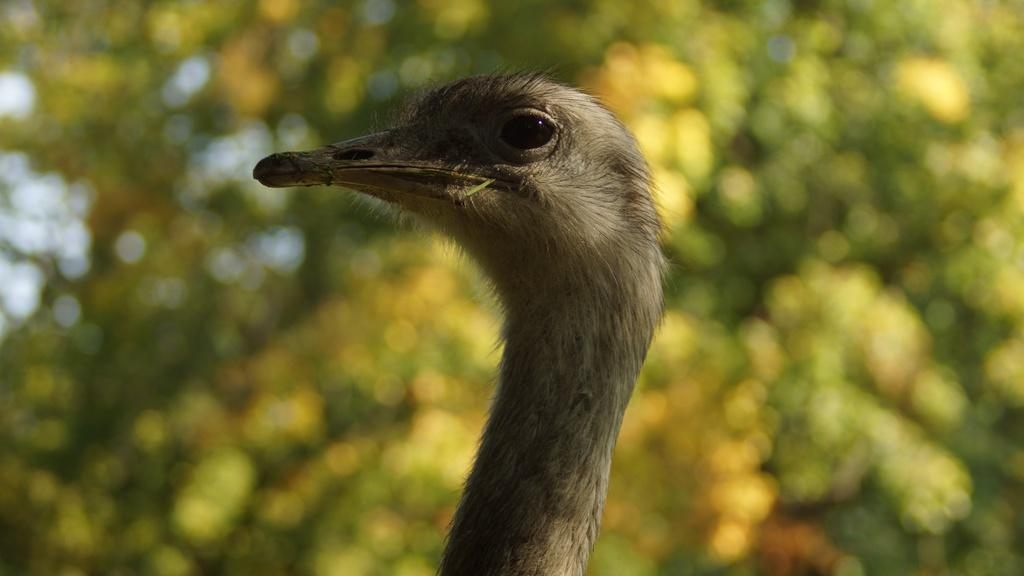What type of animal is in the image? There is a bird in the image. Can you describe the bird's appearance? The bird is cream-colored. What can be seen in the background of the image? There are trees visible in the image. What is visible at the top of the image? The sky is visible at the top of the image. What type of steel structure can be seen in the image? There is no steel structure present in the image; it features a bird and trees. How does the bird say good-bye in the image? Birds do not have the ability to say good-bye, and there is no indication of any such action in the image. 